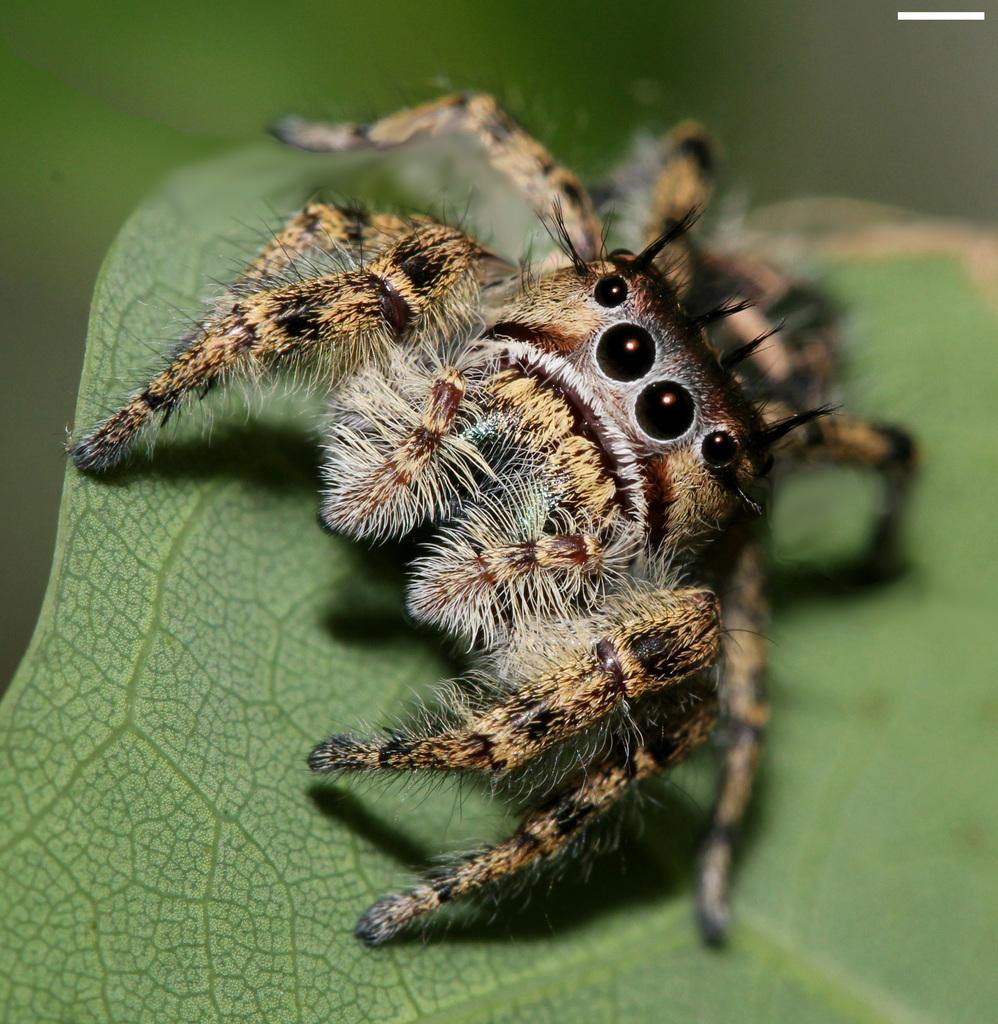What is present on the leaf in the image? There is an insect on the leaf in the image. Can you describe the insect's location in the image? The insect is on a leaf in the image. What can be observed about the background of the image? The background of the image is blurred. What type of skin condition can be seen on the insect in the image? There is no indication of a skin condition on the insect in the image, as insects do not have skin like humans or mammals. 